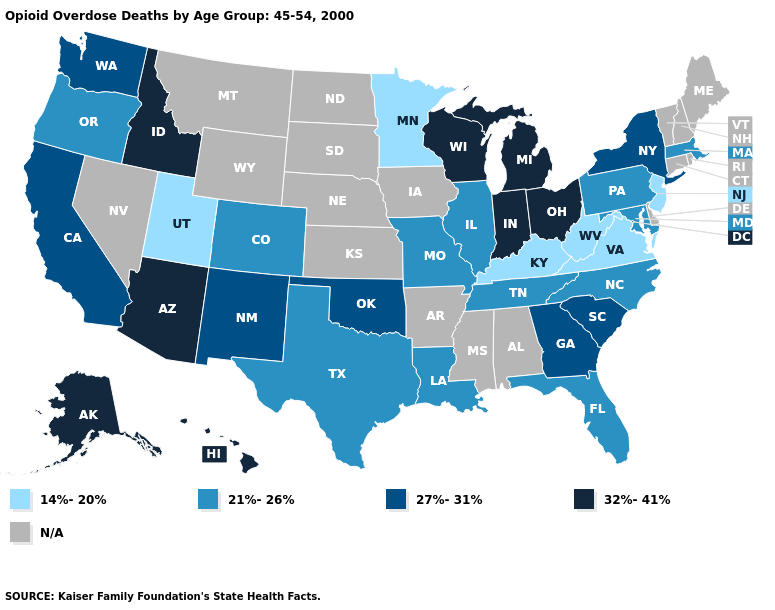Among the states that border Indiana , which have the highest value?
Give a very brief answer. Michigan, Ohio. What is the highest value in states that border Colorado?
Write a very short answer. 32%-41%. Is the legend a continuous bar?
Write a very short answer. No. Does Massachusetts have the lowest value in the Northeast?
Answer briefly. No. Name the states that have a value in the range 21%-26%?
Concise answer only. Colorado, Florida, Illinois, Louisiana, Maryland, Massachusetts, Missouri, North Carolina, Oregon, Pennsylvania, Tennessee, Texas. What is the lowest value in states that border Nebraska?
Answer briefly. 21%-26%. Does Virginia have the lowest value in the USA?
Concise answer only. Yes. Does New Jersey have the lowest value in the Northeast?
Answer briefly. Yes. Does Idaho have the highest value in the USA?
Keep it brief. Yes. What is the value of Washington?
Give a very brief answer. 27%-31%. What is the value of Virginia?
Short answer required. 14%-20%. Does Wisconsin have the lowest value in the USA?
Answer briefly. No. Among the states that border Utah , which have the highest value?
Give a very brief answer. Arizona, Idaho. 